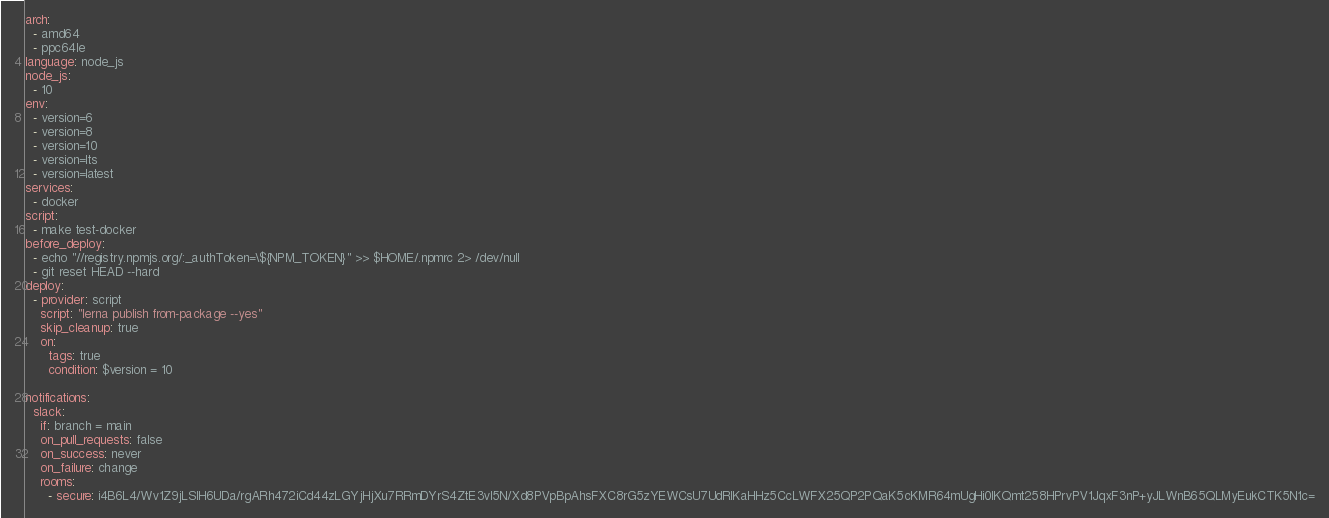Convert code to text. <code><loc_0><loc_0><loc_500><loc_500><_YAML_>arch:
  - amd64
  - ppc64le
language: node_js
node_js:
  - 10
env:
  - version=6
  - version=8
  - version=10
  - version=lts
  - version=latest
services:
  - docker
script:
  - make test-docker
before_deploy:
  - echo "//registry.npmjs.org/:_authToken=\${NPM_TOKEN}" >> $HOME/.npmrc 2> /dev/null
  - git reset HEAD --hard
deploy:
  - provider: script
    script: "lerna publish from-package --yes"
    skip_cleanup: true
    on:
      tags: true
      condition: $version = 10

notifications:
  slack:
    if: branch = main
    on_pull_requests: false
    on_success: never
    on_failure: change
    rooms:
      - secure: i4B6L4/Wv1Z9jLSIH6UDa/rgARh472iCd44zLGYjHjXu7RRmDYrS4ZtE3vl5N/Xd8PVpBpAhsFXC8rG5zYEWCsU7UdRlKaHHz5CcLWFX25QP2PQaK5cKMR64mUgHi0lKQmt258HPrvPV1JqxF3nP+yJLWnB65QLMyEukCTK5N1c=
</code> 